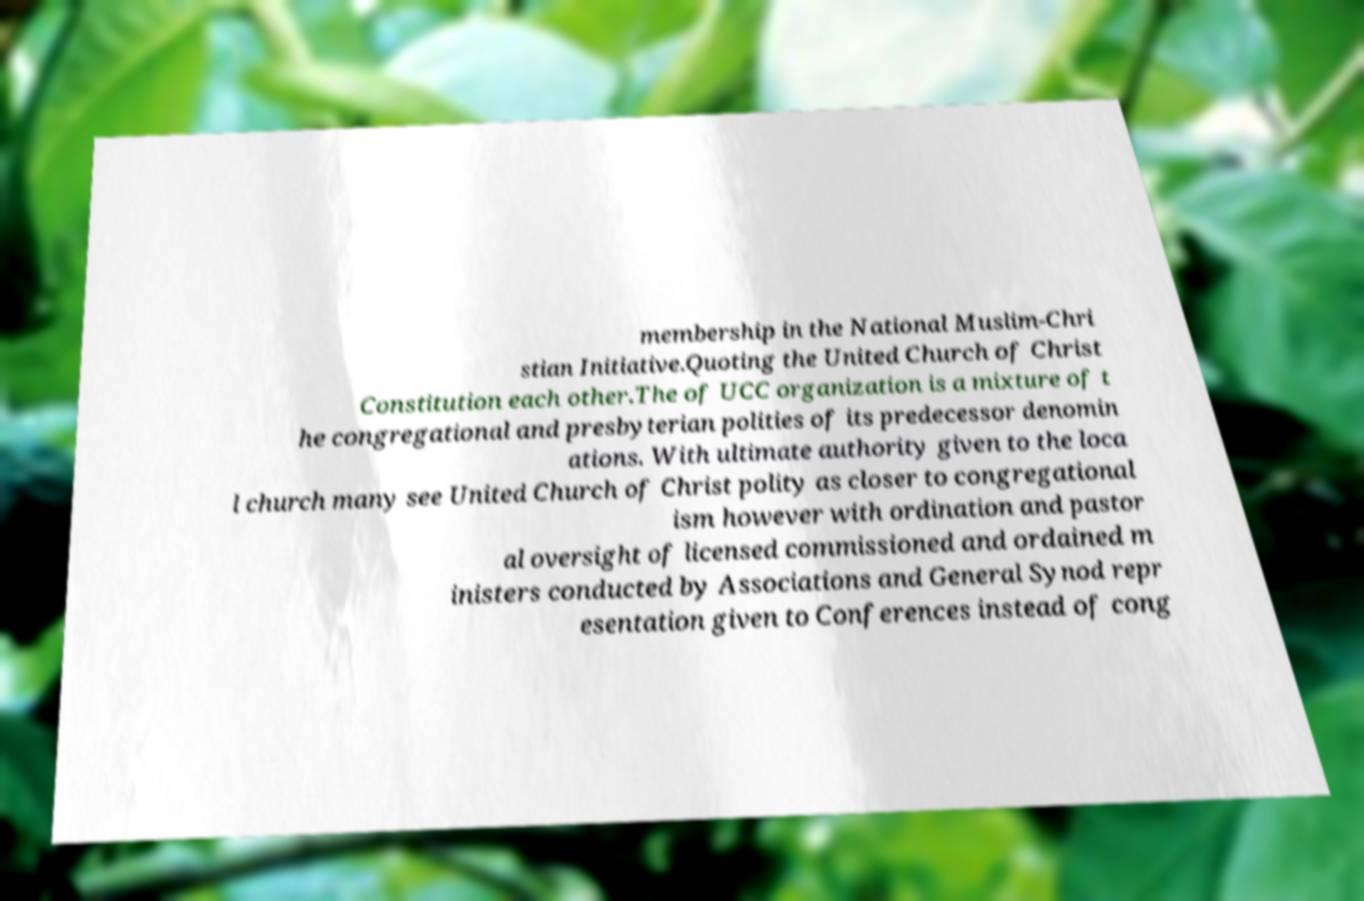Please read and relay the text visible in this image. What does it say? membership in the National Muslim-Chri stian Initiative.Quoting the United Church of Christ Constitution each other.The of UCC organization is a mixture of t he congregational and presbyterian polities of its predecessor denomin ations. With ultimate authority given to the loca l church many see United Church of Christ polity as closer to congregational ism however with ordination and pastor al oversight of licensed commissioned and ordained m inisters conducted by Associations and General Synod repr esentation given to Conferences instead of cong 